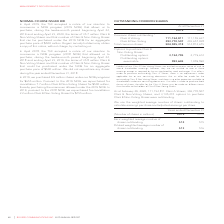According to Rogers Communications's financial document, What were the number of Class A shares outstanding as at February 29, 2020? According to the financial document, 111,154,811. The relevant text states: "Class A Voting 111,154,811 111,155,637 Class B Non-Voting 393,770,507 403,657,038 Total common shares 504,925,318 514,812,675..." Also, What were the number of Class B shares outstanding as at February 29, 2020? According to the financial document, 393,770,507. The relevant text states: "Voting 111,154,811 111,155,637 Class B Non-Voting 393,770,507 403,657,038 Total common shares 504,925,318 514,812,675..." Also, How are the terms of purchase structured in case both the classes of shares are to be purchased? If an offer is made to purchase both classes of shares, the offer for the Class A Shares may be made on different terms than the offer to the holders of Class B Non-Voting Shares.. The document states: "le to shareholders under our constating documents. If an offer is made to purchase both classes of shares, the offer for the Class A Shares may be mad..." Also, can you calculate: What is the increase / (decrease) in the Class A Voting shares from 2018 to 2019? Based on the calculation: 111,154,811 - 111,155,637, the result is -826. This is based on the information: "Class A Voting 111,154,811 111,155,637 Class B Non-Voting 393,770,507 403,657,038 Total common shares 504,925,318 514,812,675 Class A Voting 111,154,811 111,155,637 Class B Non-Voting 393,770,507 403,..." The key data points involved are: 111,154,811, 111,155,637. Also, can you calculate: What is the average Class B Non-Voting shares? To answer this question, I need to perform calculations using the financial data. The calculation is: (393,770,507 + 403,657,038) / 2, which equals 398713772.5. This is based on the information: "54,811 111,155,637 Class B Non-Voting 393,770,507 403,657,038 Total common shares 504,925,318 514,812,675 Voting 111,154,811 111,155,637 Class B Non-Voting 393,770,507 403,657,038 Total common shares ..." The key data points involved are: 393,770,507, 403,657,038. Also, can you calculate: What was the percentage increase / (decrease) in Total common shares from 2018 to 2019? To answer this question, I need to perform calculations using the financial data. The calculation is: 504,925,318 / 514,812,675 - 1, which equals -1.92 (percentage). This is based on the information: "oting 393,770,507 403,657,038 Total common shares 504,925,318 514,812,675 0,507 403,657,038 Total common shares 504,925,318 514,812,675..." The key data points involved are: 504,925,318, 514,812,675. 